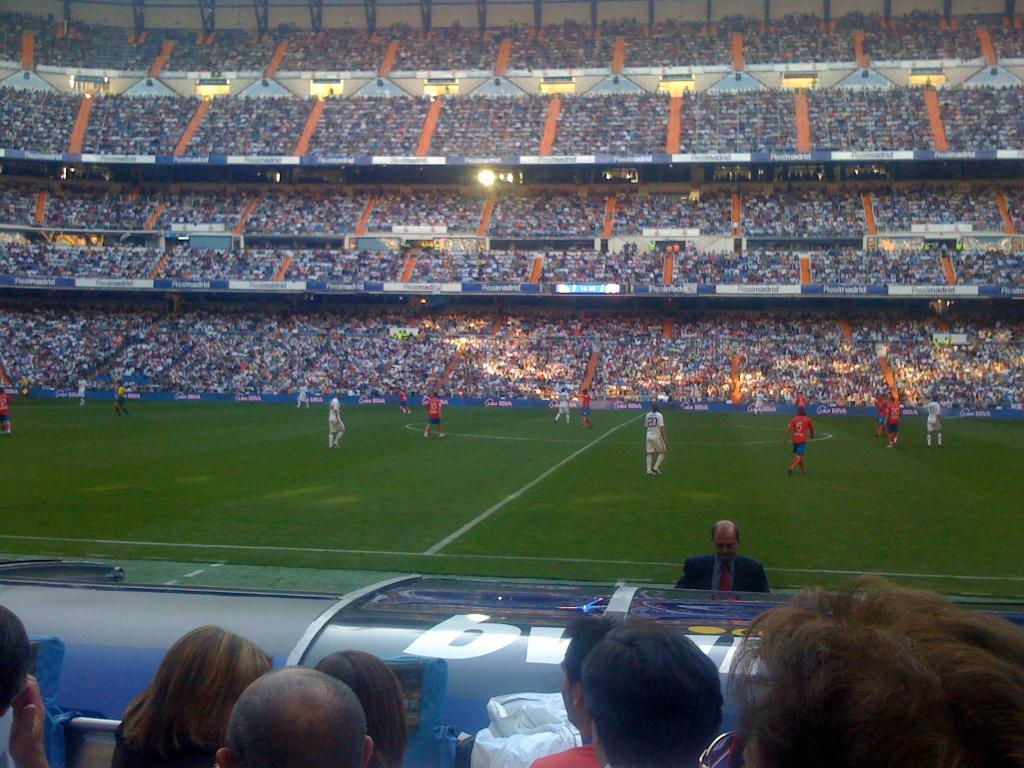What sport are the players in the image participating in? The players are playing football in the image. Where are the players located in the image? The players are on the ground. How many people can be seen in the stadium? There are many people in the stadium. Can you describe the people in the foreground? There are many people in the foreground. What type of lighting is present in the image? There is a light in the image. How many houses can be seen in the image? There are no houses visible in the image; it features a football game in a stadium. 